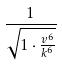Convert formula to latex. <formula><loc_0><loc_0><loc_500><loc_500>\frac { 1 } { \sqrt { 1 \cdot \frac { v ^ { 6 } } { k ^ { 6 } } } }</formula> 